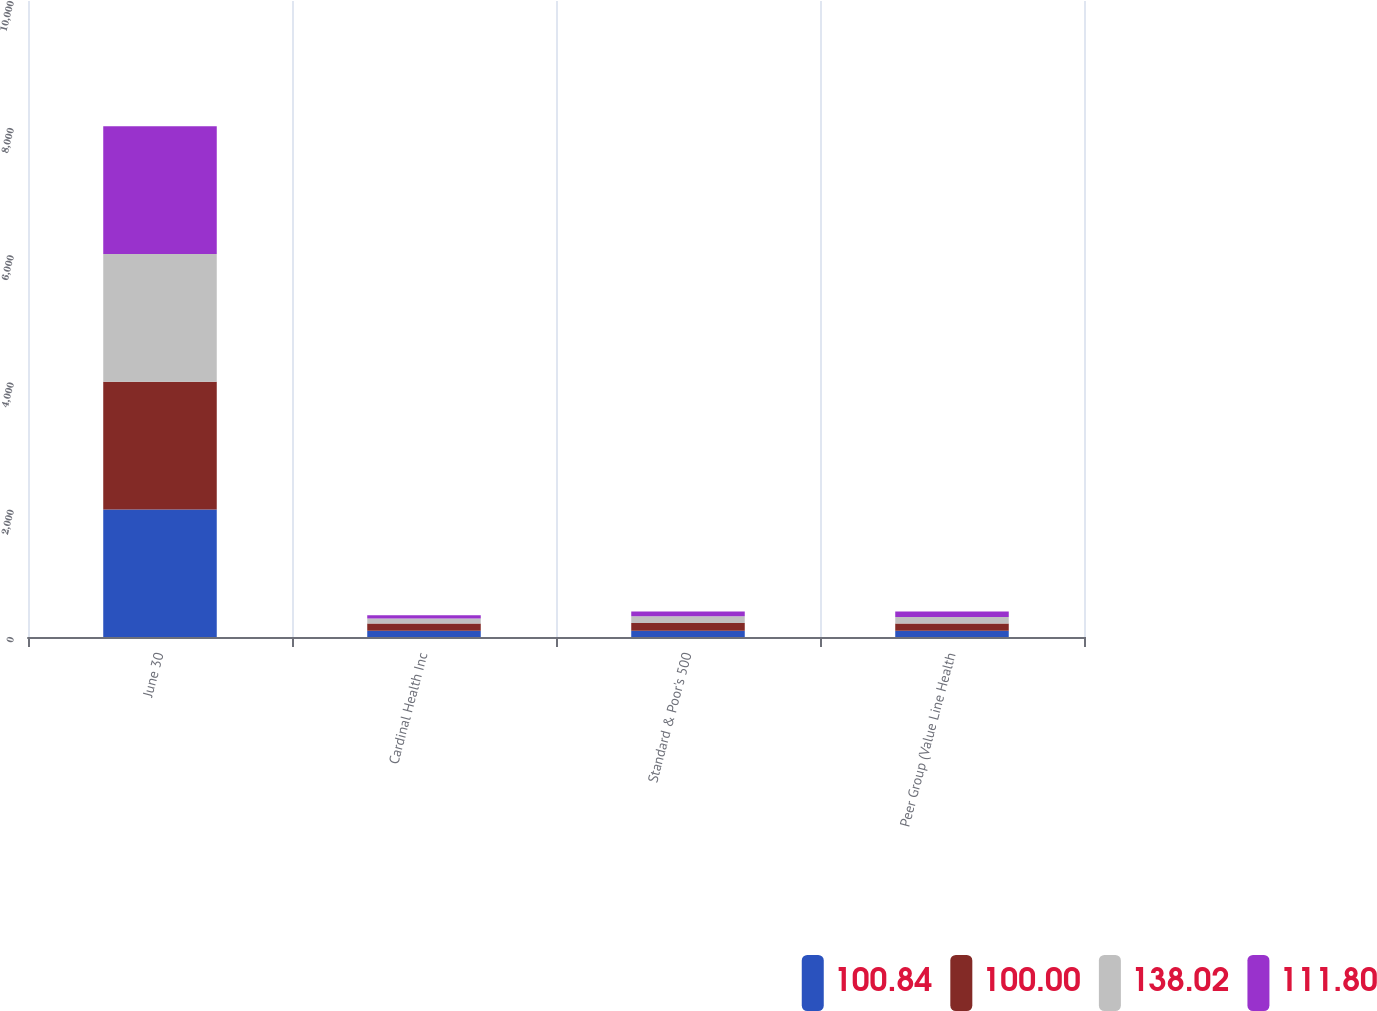<chart> <loc_0><loc_0><loc_500><loc_500><stacked_bar_chart><ecel><fcel>June 30<fcel>Cardinal Health Inc<fcel>Standard & Poor's 500<fcel>Peer Group (Value Line Health<nl><fcel>100.84<fcel>2006<fcel>100<fcel>100<fcel>100<nl><fcel>100<fcel>2007<fcel>110.44<fcel>120.59<fcel>111.8<nl><fcel>138.02<fcel>2008<fcel>81.37<fcel>104.77<fcel>100.84<nl><fcel>111.8<fcel>2009<fcel>49.03<fcel>77.31<fcel>87.18<nl></chart> 